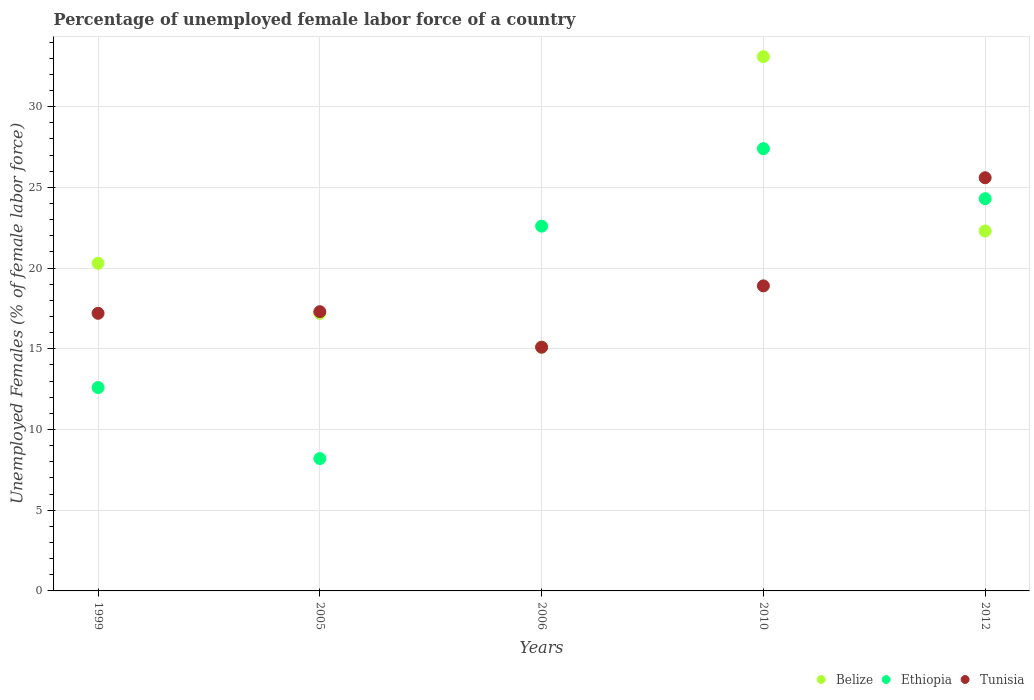Is the number of dotlines equal to the number of legend labels?
Your response must be concise. Yes. What is the percentage of unemployed female labor force in Tunisia in 2006?
Keep it short and to the point. 15.1. Across all years, what is the maximum percentage of unemployed female labor force in Ethiopia?
Your answer should be compact. 27.4. Across all years, what is the minimum percentage of unemployed female labor force in Ethiopia?
Make the answer very short. 8.2. What is the total percentage of unemployed female labor force in Tunisia in the graph?
Make the answer very short. 94.1. What is the difference between the percentage of unemployed female labor force in Tunisia in 2005 and that in 2012?
Your answer should be very brief. -8.3. What is the difference between the percentage of unemployed female labor force in Belize in 1999 and the percentage of unemployed female labor force in Ethiopia in 2005?
Your answer should be compact. 12.1. What is the average percentage of unemployed female labor force in Tunisia per year?
Give a very brief answer. 18.82. In the year 2006, what is the difference between the percentage of unemployed female labor force in Ethiopia and percentage of unemployed female labor force in Tunisia?
Ensure brevity in your answer.  7.5. In how many years, is the percentage of unemployed female labor force in Tunisia greater than 13 %?
Provide a short and direct response. 5. What is the ratio of the percentage of unemployed female labor force in Belize in 2006 to that in 2012?
Make the answer very short. 0.68. Is the difference between the percentage of unemployed female labor force in Ethiopia in 1999 and 2012 greater than the difference between the percentage of unemployed female labor force in Tunisia in 1999 and 2012?
Keep it short and to the point. No. What is the difference between the highest and the second highest percentage of unemployed female labor force in Ethiopia?
Your answer should be very brief. 3.1. What is the difference between the highest and the lowest percentage of unemployed female labor force in Belize?
Provide a short and direct response. 18. Is it the case that in every year, the sum of the percentage of unemployed female labor force in Tunisia and percentage of unemployed female labor force in Ethiopia  is greater than the percentage of unemployed female labor force in Belize?
Offer a terse response. Yes. Does the percentage of unemployed female labor force in Tunisia monotonically increase over the years?
Your response must be concise. No. Is the percentage of unemployed female labor force in Tunisia strictly greater than the percentage of unemployed female labor force in Belize over the years?
Your answer should be very brief. No. Is the percentage of unemployed female labor force in Belize strictly less than the percentage of unemployed female labor force in Tunisia over the years?
Keep it short and to the point. No. How many dotlines are there?
Your answer should be very brief. 3. How many years are there in the graph?
Give a very brief answer. 5. What is the difference between two consecutive major ticks on the Y-axis?
Make the answer very short. 5. Are the values on the major ticks of Y-axis written in scientific E-notation?
Keep it short and to the point. No. Does the graph contain any zero values?
Offer a terse response. No. How many legend labels are there?
Your answer should be compact. 3. How are the legend labels stacked?
Your answer should be very brief. Horizontal. What is the title of the graph?
Provide a short and direct response. Percentage of unemployed female labor force of a country. What is the label or title of the X-axis?
Your response must be concise. Years. What is the label or title of the Y-axis?
Your answer should be very brief. Unemployed Females (% of female labor force). What is the Unemployed Females (% of female labor force) in Belize in 1999?
Provide a succinct answer. 20.3. What is the Unemployed Females (% of female labor force) in Ethiopia in 1999?
Make the answer very short. 12.6. What is the Unemployed Females (% of female labor force) in Tunisia in 1999?
Offer a very short reply. 17.2. What is the Unemployed Females (% of female labor force) of Belize in 2005?
Offer a terse response. 17.2. What is the Unemployed Females (% of female labor force) of Ethiopia in 2005?
Keep it short and to the point. 8.2. What is the Unemployed Females (% of female labor force) of Tunisia in 2005?
Keep it short and to the point. 17.3. What is the Unemployed Females (% of female labor force) of Belize in 2006?
Ensure brevity in your answer.  15.1. What is the Unemployed Females (% of female labor force) of Ethiopia in 2006?
Provide a succinct answer. 22.6. What is the Unemployed Females (% of female labor force) of Tunisia in 2006?
Give a very brief answer. 15.1. What is the Unemployed Females (% of female labor force) in Belize in 2010?
Provide a short and direct response. 33.1. What is the Unemployed Females (% of female labor force) in Ethiopia in 2010?
Give a very brief answer. 27.4. What is the Unemployed Females (% of female labor force) in Tunisia in 2010?
Provide a short and direct response. 18.9. What is the Unemployed Females (% of female labor force) in Belize in 2012?
Offer a very short reply. 22.3. What is the Unemployed Females (% of female labor force) of Ethiopia in 2012?
Offer a terse response. 24.3. What is the Unemployed Females (% of female labor force) in Tunisia in 2012?
Offer a terse response. 25.6. Across all years, what is the maximum Unemployed Females (% of female labor force) in Belize?
Make the answer very short. 33.1. Across all years, what is the maximum Unemployed Females (% of female labor force) of Ethiopia?
Keep it short and to the point. 27.4. Across all years, what is the maximum Unemployed Females (% of female labor force) of Tunisia?
Your answer should be very brief. 25.6. Across all years, what is the minimum Unemployed Females (% of female labor force) of Belize?
Offer a terse response. 15.1. Across all years, what is the minimum Unemployed Females (% of female labor force) in Ethiopia?
Keep it short and to the point. 8.2. Across all years, what is the minimum Unemployed Females (% of female labor force) in Tunisia?
Offer a very short reply. 15.1. What is the total Unemployed Females (% of female labor force) of Belize in the graph?
Provide a short and direct response. 108. What is the total Unemployed Females (% of female labor force) in Ethiopia in the graph?
Offer a terse response. 95.1. What is the total Unemployed Females (% of female labor force) in Tunisia in the graph?
Keep it short and to the point. 94.1. What is the difference between the Unemployed Females (% of female labor force) in Belize in 1999 and that in 2005?
Ensure brevity in your answer.  3.1. What is the difference between the Unemployed Females (% of female labor force) of Ethiopia in 1999 and that in 2005?
Provide a succinct answer. 4.4. What is the difference between the Unemployed Females (% of female labor force) in Ethiopia in 1999 and that in 2006?
Your answer should be compact. -10. What is the difference between the Unemployed Females (% of female labor force) of Ethiopia in 1999 and that in 2010?
Make the answer very short. -14.8. What is the difference between the Unemployed Females (% of female labor force) in Ethiopia in 1999 and that in 2012?
Provide a short and direct response. -11.7. What is the difference between the Unemployed Females (% of female labor force) in Belize in 2005 and that in 2006?
Offer a very short reply. 2.1. What is the difference between the Unemployed Females (% of female labor force) in Ethiopia in 2005 and that in 2006?
Make the answer very short. -14.4. What is the difference between the Unemployed Females (% of female labor force) of Belize in 2005 and that in 2010?
Provide a succinct answer. -15.9. What is the difference between the Unemployed Females (% of female labor force) in Ethiopia in 2005 and that in 2010?
Your response must be concise. -19.2. What is the difference between the Unemployed Females (% of female labor force) of Tunisia in 2005 and that in 2010?
Provide a short and direct response. -1.6. What is the difference between the Unemployed Females (% of female labor force) in Belize in 2005 and that in 2012?
Keep it short and to the point. -5.1. What is the difference between the Unemployed Females (% of female labor force) in Ethiopia in 2005 and that in 2012?
Offer a terse response. -16.1. What is the difference between the Unemployed Females (% of female labor force) of Tunisia in 2005 and that in 2012?
Give a very brief answer. -8.3. What is the difference between the Unemployed Females (% of female labor force) of Ethiopia in 2006 and that in 2010?
Offer a very short reply. -4.8. What is the difference between the Unemployed Females (% of female labor force) in Ethiopia in 2006 and that in 2012?
Keep it short and to the point. -1.7. What is the difference between the Unemployed Females (% of female labor force) of Ethiopia in 2010 and that in 2012?
Your response must be concise. 3.1. What is the difference between the Unemployed Females (% of female labor force) of Tunisia in 2010 and that in 2012?
Offer a terse response. -6.7. What is the difference between the Unemployed Females (% of female labor force) in Belize in 1999 and the Unemployed Females (% of female labor force) in Tunisia in 2005?
Keep it short and to the point. 3. What is the difference between the Unemployed Females (% of female labor force) of Ethiopia in 1999 and the Unemployed Females (% of female labor force) of Tunisia in 2005?
Offer a terse response. -4.7. What is the difference between the Unemployed Females (% of female labor force) of Belize in 1999 and the Unemployed Females (% of female labor force) of Ethiopia in 2006?
Offer a terse response. -2.3. What is the difference between the Unemployed Females (% of female labor force) of Belize in 1999 and the Unemployed Females (% of female labor force) of Tunisia in 2006?
Offer a terse response. 5.2. What is the difference between the Unemployed Females (% of female labor force) in Belize in 1999 and the Unemployed Females (% of female labor force) in Tunisia in 2010?
Offer a very short reply. 1.4. What is the difference between the Unemployed Females (% of female labor force) in Belize in 1999 and the Unemployed Females (% of female labor force) in Ethiopia in 2012?
Ensure brevity in your answer.  -4. What is the difference between the Unemployed Females (% of female labor force) of Belize in 1999 and the Unemployed Females (% of female labor force) of Tunisia in 2012?
Keep it short and to the point. -5.3. What is the difference between the Unemployed Females (% of female labor force) in Ethiopia in 2005 and the Unemployed Females (% of female labor force) in Tunisia in 2006?
Give a very brief answer. -6.9. What is the difference between the Unemployed Females (% of female labor force) in Ethiopia in 2005 and the Unemployed Females (% of female labor force) in Tunisia in 2010?
Keep it short and to the point. -10.7. What is the difference between the Unemployed Females (% of female labor force) of Belize in 2005 and the Unemployed Females (% of female labor force) of Tunisia in 2012?
Keep it short and to the point. -8.4. What is the difference between the Unemployed Females (% of female labor force) of Ethiopia in 2005 and the Unemployed Females (% of female labor force) of Tunisia in 2012?
Provide a succinct answer. -17.4. What is the difference between the Unemployed Females (% of female labor force) of Belize in 2006 and the Unemployed Females (% of female labor force) of Tunisia in 2010?
Keep it short and to the point. -3.8. What is the difference between the Unemployed Females (% of female labor force) of Belize in 2006 and the Unemployed Females (% of female labor force) of Ethiopia in 2012?
Your answer should be compact. -9.2. What is the difference between the Unemployed Females (% of female labor force) in Belize in 2006 and the Unemployed Females (% of female labor force) in Tunisia in 2012?
Offer a very short reply. -10.5. What is the difference between the Unemployed Females (% of female labor force) in Ethiopia in 2010 and the Unemployed Females (% of female labor force) in Tunisia in 2012?
Ensure brevity in your answer.  1.8. What is the average Unemployed Females (% of female labor force) of Belize per year?
Offer a terse response. 21.6. What is the average Unemployed Females (% of female labor force) of Ethiopia per year?
Ensure brevity in your answer.  19.02. What is the average Unemployed Females (% of female labor force) of Tunisia per year?
Keep it short and to the point. 18.82. In the year 1999, what is the difference between the Unemployed Females (% of female labor force) in Belize and Unemployed Females (% of female labor force) in Ethiopia?
Your answer should be compact. 7.7. In the year 2005, what is the difference between the Unemployed Females (% of female labor force) in Belize and Unemployed Females (% of female labor force) in Ethiopia?
Provide a short and direct response. 9. In the year 2005, what is the difference between the Unemployed Females (% of female labor force) of Ethiopia and Unemployed Females (% of female labor force) of Tunisia?
Provide a succinct answer. -9.1. In the year 2006, what is the difference between the Unemployed Females (% of female labor force) of Belize and Unemployed Females (% of female labor force) of Ethiopia?
Your answer should be compact. -7.5. In the year 2006, what is the difference between the Unemployed Females (% of female labor force) of Ethiopia and Unemployed Females (% of female labor force) of Tunisia?
Keep it short and to the point. 7.5. In the year 2010, what is the difference between the Unemployed Females (% of female labor force) in Ethiopia and Unemployed Females (% of female labor force) in Tunisia?
Make the answer very short. 8.5. In the year 2012, what is the difference between the Unemployed Females (% of female labor force) in Belize and Unemployed Females (% of female labor force) in Ethiopia?
Provide a short and direct response. -2. What is the ratio of the Unemployed Females (% of female labor force) of Belize in 1999 to that in 2005?
Offer a very short reply. 1.18. What is the ratio of the Unemployed Females (% of female labor force) of Ethiopia in 1999 to that in 2005?
Keep it short and to the point. 1.54. What is the ratio of the Unemployed Females (% of female labor force) in Tunisia in 1999 to that in 2005?
Keep it short and to the point. 0.99. What is the ratio of the Unemployed Females (% of female labor force) of Belize in 1999 to that in 2006?
Provide a short and direct response. 1.34. What is the ratio of the Unemployed Females (% of female labor force) in Ethiopia in 1999 to that in 2006?
Make the answer very short. 0.56. What is the ratio of the Unemployed Females (% of female labor force) in Tunisia in 1999 to that in 2006?
Your response must be concise. 1.14. What is the ratio of the Unemployed Females (% of female labor force) of Belize in 1999 to that in 2010?
Provide a succinct answer. 0.61. What is the ratio of the Unemployed Females (% of female labor force) of Ethiopia in 1999 to that in 2010?
Your answer should be very brief. 0.46. What is the ratio of the Unemployed Females (% of female labor force) in Tunisia in 1999 to that in 2010?
Ensure brevity in your answer.  0.91. What is the ratio of the Unemployed Females (% of female labor force) of Belize in 1999 to that in 2012?
Keep it short and to the point. 0.91. What is the ratio of the Unemployed Females (% of female labor force) in Ethiopia in 1999 to that in 2012?
Your answer should be very brief. 0.52. What is the ratio of the Unemployed Females (% of female labor force) in Tunisia in 1999 to that in 2012?
Provide a short and direct response. 0.67. What is the ratio of the Unemployed Females (% of female labor force) of Belize in 2005 to that in 2006?
Keep it short and to the point. 1.14. What is the ratio of the Unemployed Females (% of female labor force) of Ethiopia in 2005 to that in 2006?
Keep it short and to the point. 0.36. What is the ratio of the Unemployed Females (% of female labor force) of Tunisia in 2005 to that in 2006?
Ensure brevity in your answer.  1.15. What is the ratio of the Unemployed Females (% of female labor force) in Belize in 2005 to that in 2010?
Ensure brevity in your answer.  0.52. What is the ratio of the Unemployed Females (% of female labor force) in Ethiopia in 2005 to that in 2010?
Offer a very short reply. 0.3. What is the ratio of the Unemployed Females (% of female labor force) of Tunisia in 2005 to that in 2010?
Your answer should be compact. 0.92. What is the ratio of the Unemployed Females (% of female labor force) in Belize in 2005 to that in 2012?
Your answer should be very brief. 0.77. What is the ratio of the Unemployed Females (% of female labor force) of Ethiopia in 2005 to that in 2012?
Offer a terse response. 0.34. What is the ratio of the Unemployed Females (% of female labor force) of Tunisia in 2005 to that in 2012?
Your answer should be compact. 0.68. What is the ratio of the Unemployed Females (% of female labor force) in Belize in 2006 to that in 2010?
Your response must be concise. 0.46. What is the ratio of the Unemployed Females (% of female labor force) in Ethiopia in 2006 to that in 2010?
Your answer should be compact. 0.82. What is the ratio of the Unemployed Females (% of female labor force) in Tunisia in 2006 to that in 2010?
Your answer should be compact. 0.8. What is the ratio of the Unemployed Females (% of female labor force) of Belize in 2006 to that in 2012?
Offer a very short reply. 0.68. What is the ratio of the Unemployed Females (% of female labor force) in Ethiopia in 2006 to that in 2012?
Give a very brief answer. 0.93. What is the ratio of the Unemployed Females (% of female labor force) in Tunisia in 2006 to that in 2012?
Provide a succinct answer. 0.59. What is the ratio of the Unemployed Females (% of female labor force) in Belize in 2010 to that in 2012?
Provide a succinct answer. 1.48. What is the ratio of the Unemployed Females (% of female labor force) in Ethiopia in 2010 to that in 2012?
Your response must be concise. 1.13. What is the ratio of the Unemployed Females (% of female labor force) of Tunisia in 2010 to that in 2012?
Your answer should be very brief. 0.74. What is the difference between the highest and the lowest Unemployed Females (% of female labor force) in Belize?
Ensure brevity in your answer.  18. What is the difference between the highest and the lowest Unemployed Females (% of female labor force) in Tunisia?
Your response must be concise. 10.5. 